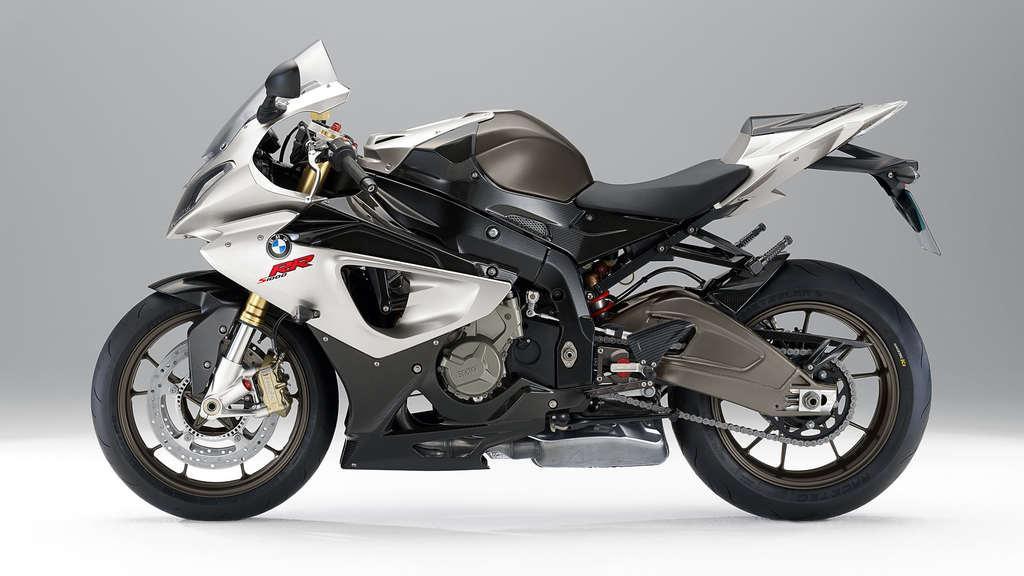How would you summarize this image in a sentence or two? In this image we can see a motorcycle on the white color surface. 